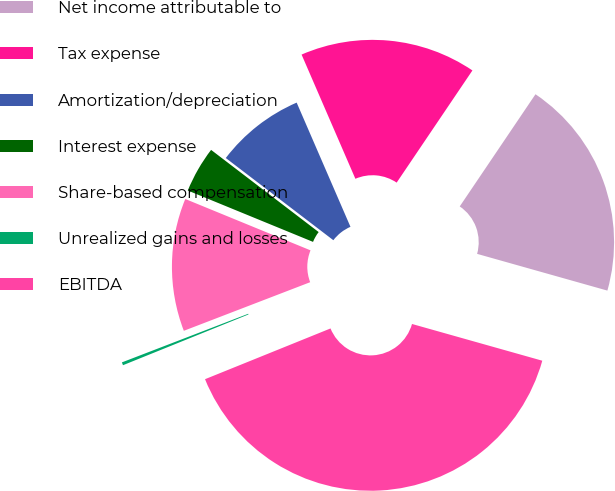<chart> <loc_0><loc_0><loc_500><loc_500><pie_chart><fcel>Net income attributable to<fcel>Tax expense<fcel>Amortization/depreciation<fcel>Interest expense<fcel>Share-based compensation<fcel>Unrealized gains and losses<fcel>EBITDA<nl><fcel>19.92%<fcel>15.96%<fcel>8.11%<fcel>4.19%<fcel>12.04%<fcel>0.27%<fcel>39.51%<nl></chart> 